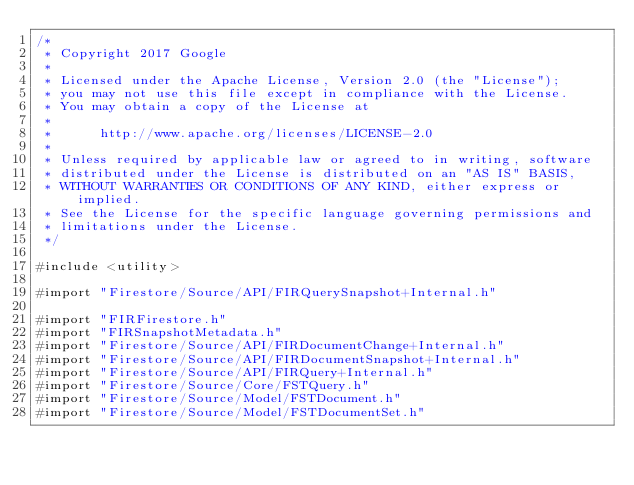<code> <loc_0><loc_0><loc_500><loc_500><_ObjectiveC_>/*
 * Copyright 2017 Google
 *
 * Licensed under the Apache License, Version 2.0 (the "License");
 * you may not use this file except in compliance with the License.
 * You may obtain a copy of the License at
 *
 *      http://www.apache.org/licenses/LICENSE-2.0
 *
 * Unless required by applicable law or agreed to in writing, software
 * distributed under the License is distributed on an "AS IS" BASIS,
 * WITHOUT WARRANTIES OR CONDITIONS OF ANY KIND, either express or implied.
 * See the License for the specific language governing permissions and
 * limitations under the License.
 */

#include <utility>

#import "Firestore/Source/API/FIRQuerySnapshot+Internal.h"

#import "FIRFirestore.h"
#import "FIRSnapshotMetadata.h"
#import "Firestore/Source/API/FIRDocumentChange+Internal.h"
#import "Firestore/Source/API/FIRDocumentSnapshot+Internal.h"
#import "Firestore/Source/API/FIRQuery+Internal.h"
#import "Firestore/Source/Core/FSTQuery.h"
#import "Firestore/Source/Model/FSTDocument.h"
#import "Firestore/Source/Model/FSTDocumentSet.h"</code> 